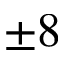Convert formula to latex. <formula><loc_0><loc_0><loc_500><loc_500>\pm 8</formula> 